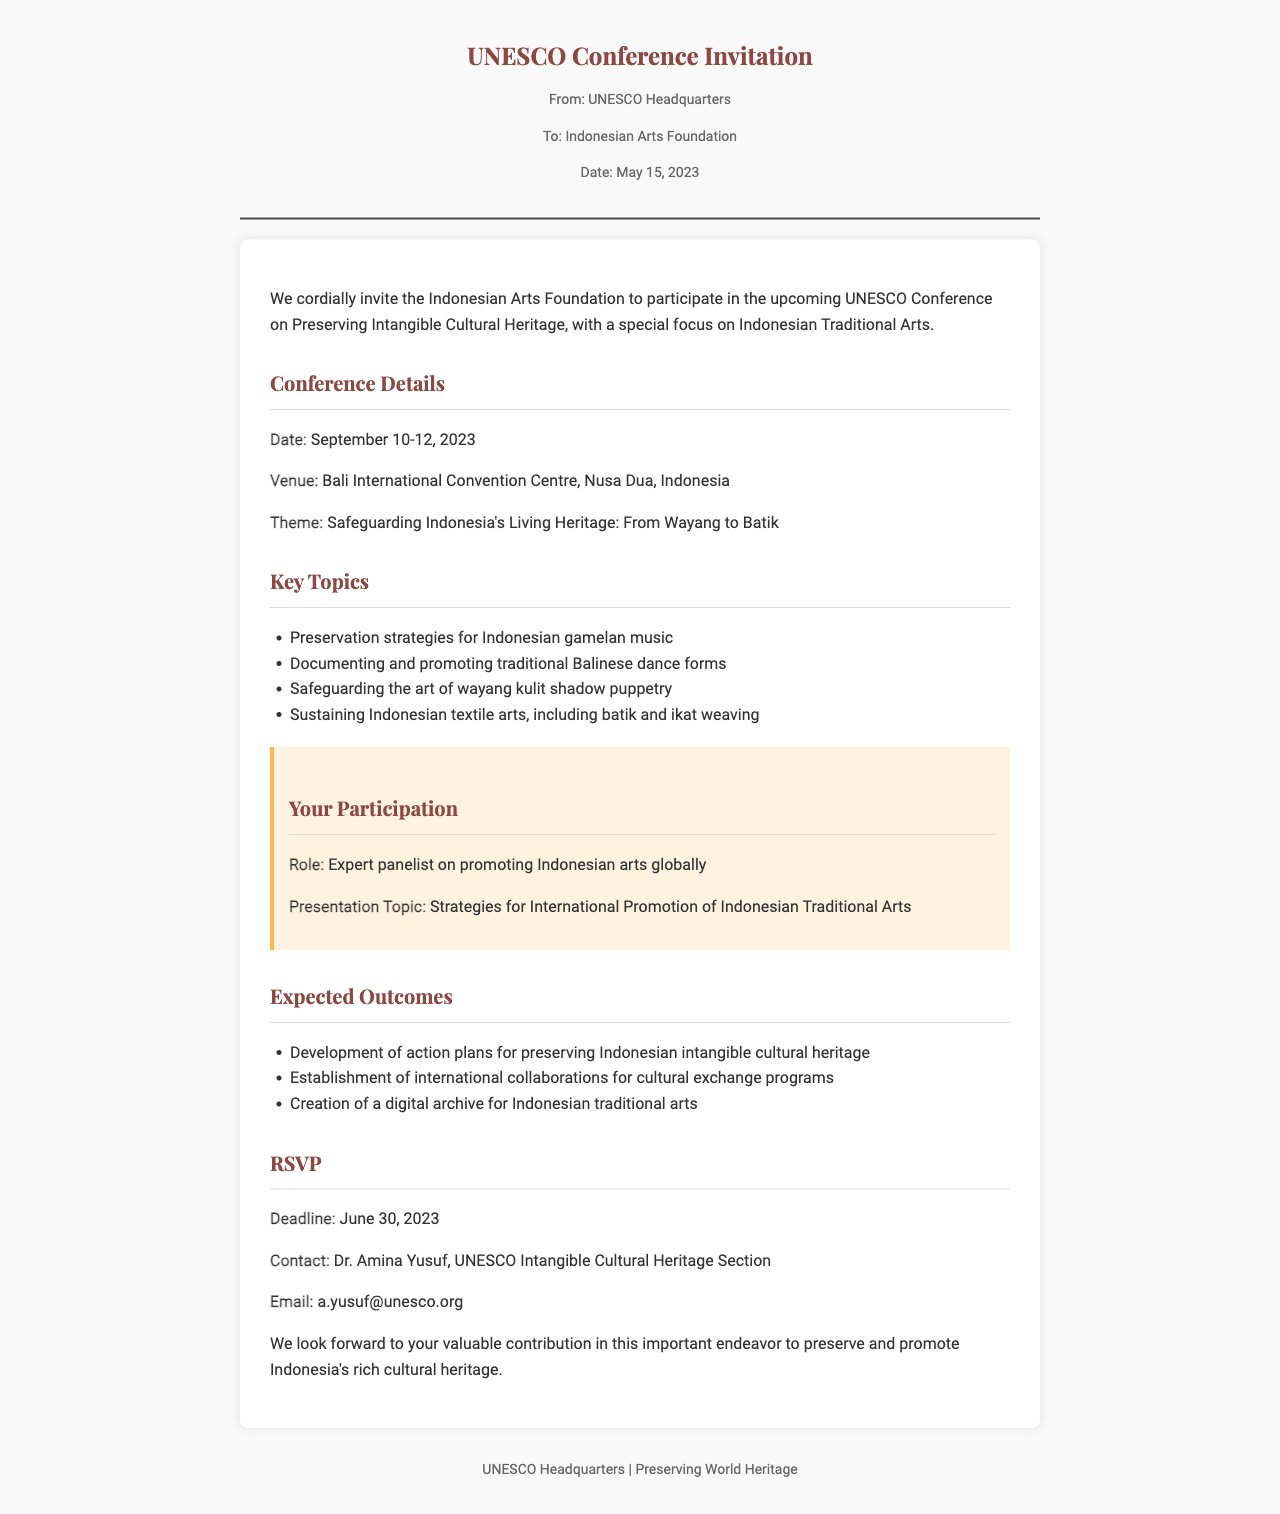What is the date of the conference? The date of the conference is specified in the document as September 10-12, 2023.
Answer: September 10-12, 2023 Who is the contact person for the RSVP? The document states that Dr. Amina Yusuf is the contact person for the RSVP.
Answer: Dr. Amina Yusuf What is the theme of the conference? The theme of the conference is highlighted in the document as "Safeguarding Indonesia's Living Heritage: From Wayang to Batik."
Answer: Safeguarding Indonesia's Living Heritage: From Wayang to Batik What is the deadline for RSVP? The document specifies that the deadline for RSVP is June 30, 2023.
Answer: June 30, 2023 What is the role of the Indonesian Arts Foundation at the conference? The document mentions that the role of the Indonesian Arts Foundation is as an expert panelist on promoting Indonesian arts globally.
Answer: Expert panelist on promoting Indonesian arts globally What is one expected outcome of the conference? One of the expected outcomes mentioned is the "Development of action plans for preserving Indonesian intangible cultural heritage."
Answer: Development of action plans for preserving Indonesian intangible cultural heritage What venue will host the conference? The document states that the conference will be held at Bali International Convention Centre, Nusa Dua, Indonesia.
Answer: Bali International Convention Centre, Nusa Dua, Indonesia What is the presentation topic for the Indonesian Arts Foundation? The presentation topic is described in the document as "Strategies for International Promotion of Indonesian Traditional Arts."
Answer: Strategies for International Promotion of Indonesian Traditional Arts 